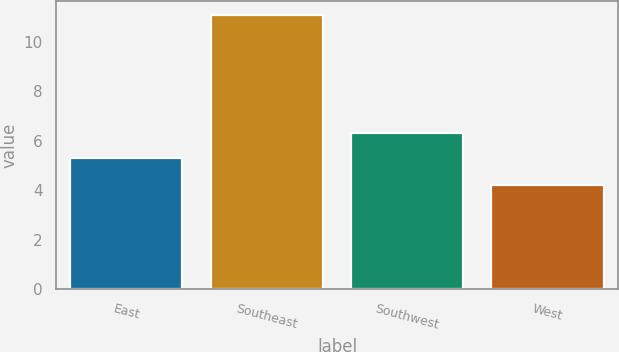Convert chart to OTSL. <chart><loc_0><loc_0><loc_500><loc_500><bar_chart><fcel>East<fcel>Southeast<fcel>Southwest<fcel>West<nl><fcel>5.3<fcel>11.1<fcel>6.3<fcel>4.2<nl></chart> 